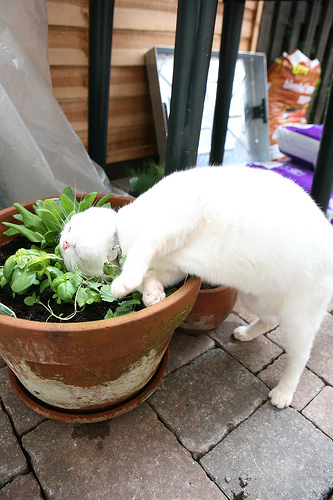Dive deep into the significance of the texture on the stones. The texture of the stones on the sidewalk plays a crucial role in setting the ambiance of the scene. Each stone's uneven surface and irregular shape suggest a sense of rustic charm. It's possible that these stones have been walked on frequently, each step etching tiny marks and adding to their unique texture. This texture also provides a sensory experience for the animals that walk across it, including the cat in the image. For the human observers, the texture of the stones evokes a feeling of nostalgia and history, making the scene feel lived-in and authentic. 